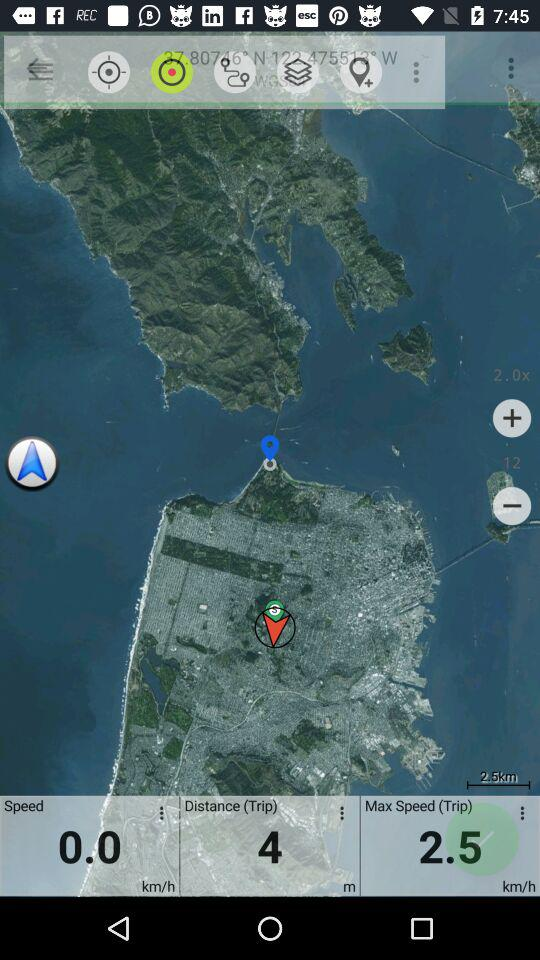What is the max speed in km/h?
Answer the question using a single word or phrase. 2.5 